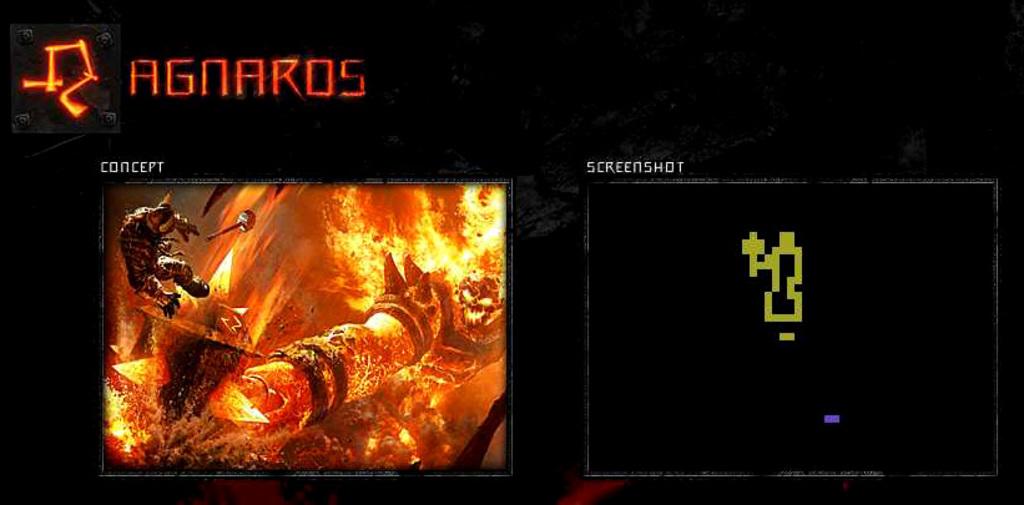What do the red letters say?
Make the answer very short. Agnaros. The picture on the right is described as a?
Offer a terse response. Screenshot. 